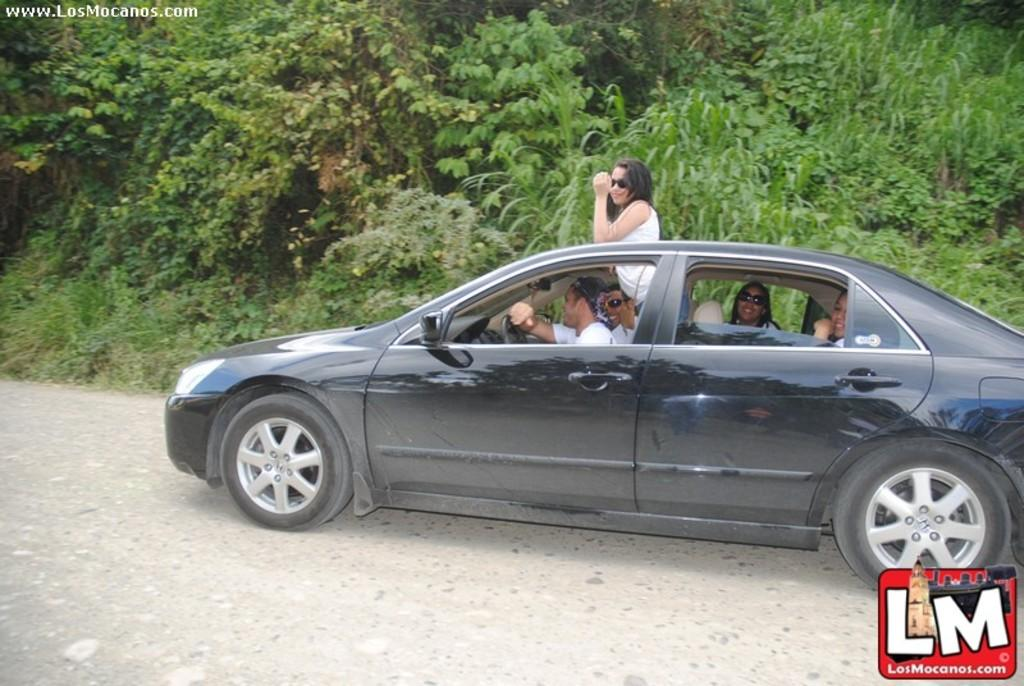How many people are in the image? There is a group of people in the image. What are some of the people doing in the image? Some of the people are seated in a car. What is the woman beside the car doing? A woman is standing beside the car. What can be seen in the background of the image? There are trees visible in the image. What type of beetle can be seen crawling on the woman's shoulder in the image? There is no beetle present on the woman's shoulder in the image. What emotion is the woman expressing towards the people in the car in the image? The image does not provide information about the woman's emotions or feelings towards the people in the car. 